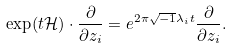<formula> <loc_0><loc_0><loc_500><loc_500>\exp ( t \mathcal { H } ) \cdot \frac { \partial } { \partial z _ { i } } = e ^ { 2 \pi \sqrt { - 1 } \lambda _ { i } t } \frac { \partial } { \partial z _ { i } } .</formula> 